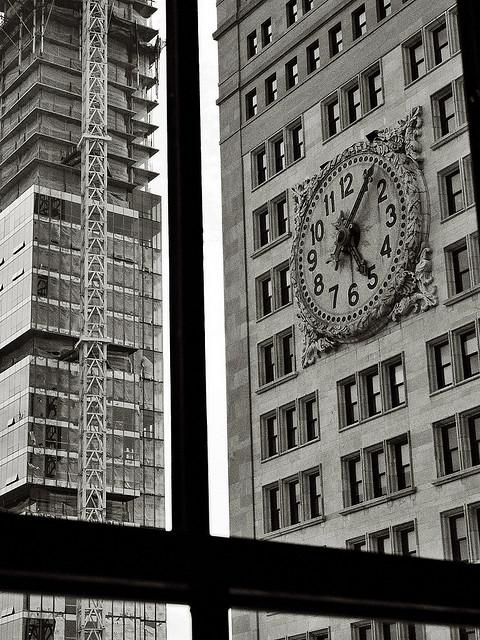What color is the border around the clock?
Answer briefly. Gray. Could the time be 5:06 PM?
Write a very short answer. Yes. What's the time on the clock?
Concise answer only. 5:06. Was the picture taken from outside?
Answer briefly. No. Is the iron fence ornate?
Write a very short answer. No. What time does the clock say?
Quick response, please. 5:06. What color is the clock?
Answer briefly. Gray. What time was this photo taken?
Concise answer only. 5:05. What time does the clock read?
Write a very short answer. 5:05. Are the parts of this clock messing?
Answer briefly. No. Does the building have a balcony?
Write a very short answer. No. What direction is the arrow pointing?
Give a very brief answer. Right. What script are the numbers written in?
Keep it brief. Numbers. What kind do numbers are on the clock face?
Write a very short answer. Regular numbers. What time is it?
Be succinct. 5:07. What color is the  clock?
Give a very brief answer. White. What is on the side of the building?
Quick response, please. Clock. What is the symbol on the bottom half o the clock?
Be succinct. 6. Is that a tree the clock is on?
Concise answer only. No. How many stories is the building?
Concise answer only. 30. What color is the clock's face?
Quick response, please. White. Where is the clock?
Concise answer only. On building. How many floors are pictured?
Answer briefly. 10. 